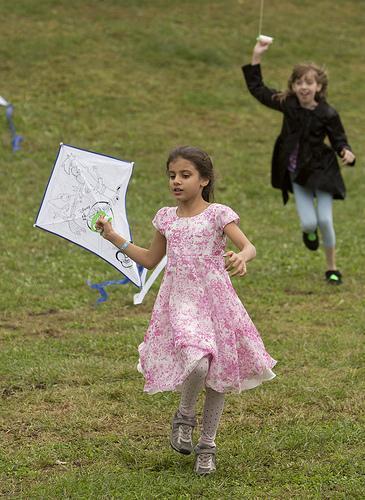How many people are in the scene?
Give a very brief answer. 2. 